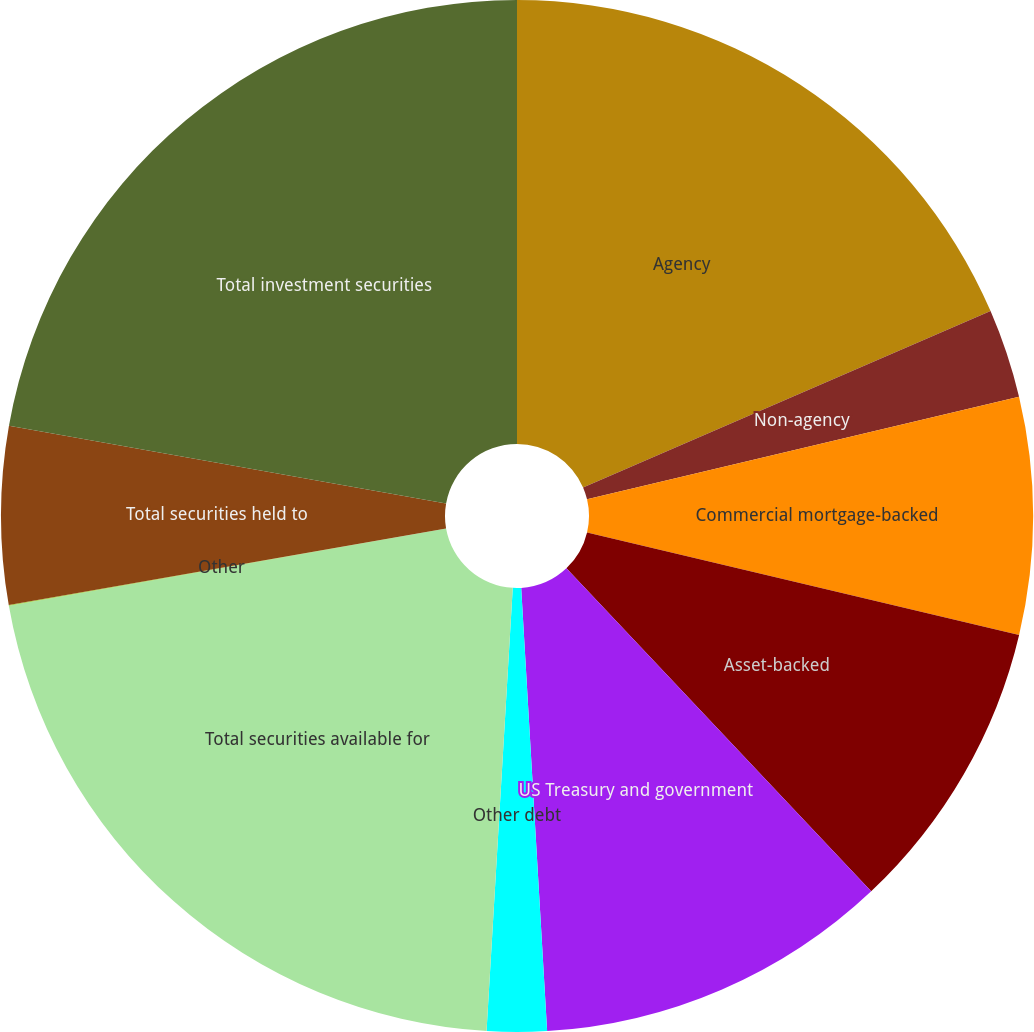Convert chart. <chart><loc_0><loc_0><loc_500><loc_500><pie_chart><fcel>Agency<fcel>Non-agency<fcel>Commercial mortgage-backed<fcel>Asset-backed<fcel>US Treasury and government<fcel>Other debt<fcel>Total securities available for<fcel>Other<fcel>Total securities held to<fcel>Total investment securities<nl><fcel>18.5%<fcel>2.79%<fcel>7.41%<fcel>9.26%<fcel>11.11%<fcel>1.87%<fcel>21.28%<fcel>0.02%<fcel>5.56%<fcel>22.2%<nl></chart> 